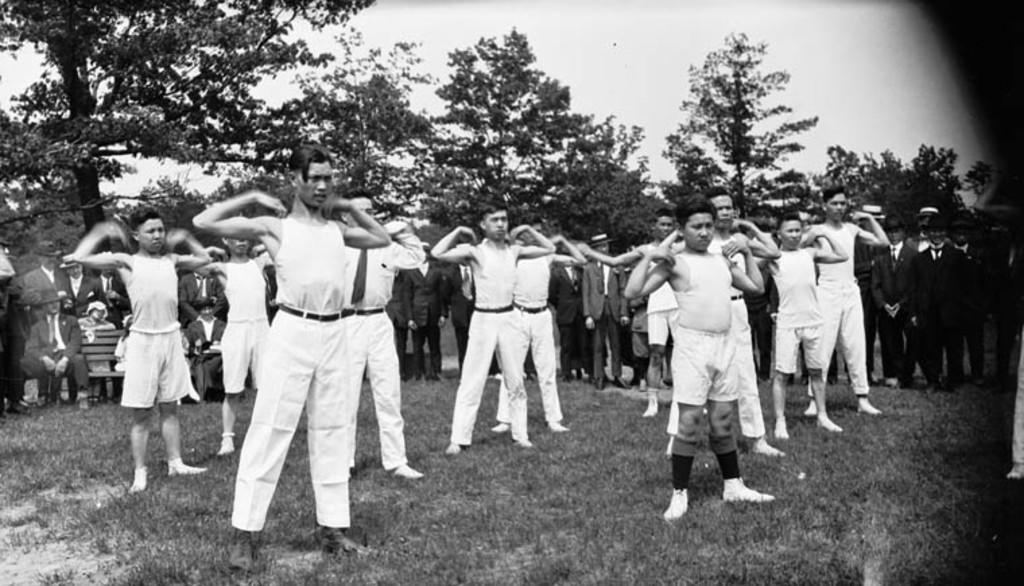Who or what can be seen in the image? There are people in the image. What are some of the people wearing? Some people in the image are wearing suits. What type of natural environment is visible in the image? There are trees visible in the image. What type of discovery was made by the sheep in the image? There are no sheep present in the image, so no discovery can be attributed to them. 